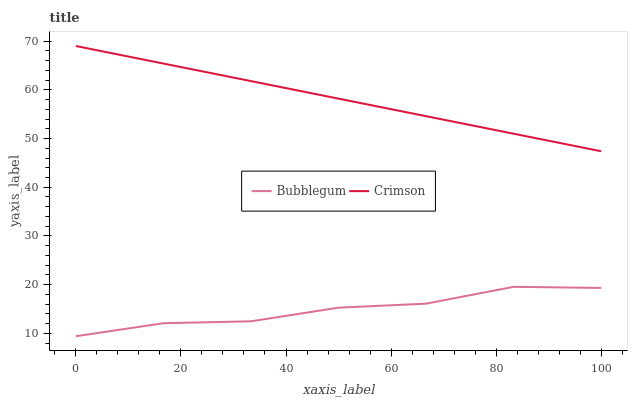Does Bubblegum have the minimum area under the curve?
Answer yes or no. Yes. Does Crimson have the maximum area under the curve?
Answer yes or no. Yes. Does Bubblegum have the maximum area under the curve?
Answer yes or no. No. Is Crimson the smoothest?
Answer yes or no. Yes. Is Bubblegum the roughest?
Answer yes or no. Yes. Is Bubblegum the smoothest?
Answer yes or no. No. Does Bubblegum have the lowest value?
Answer yes or no. Yes. Does Crimson have the highest value?
Answer yes or no. Yes. Does Bubblegum have the highest value?
Answer yes or no. No. Is Bubblegum less than Crimson?
Answer yes or no. Yes. Is Crimson greater than Bubblegum?
Answer yes or no. Yes. Does Bubblegum intersect Crimson?
Answer yes or no. No. 